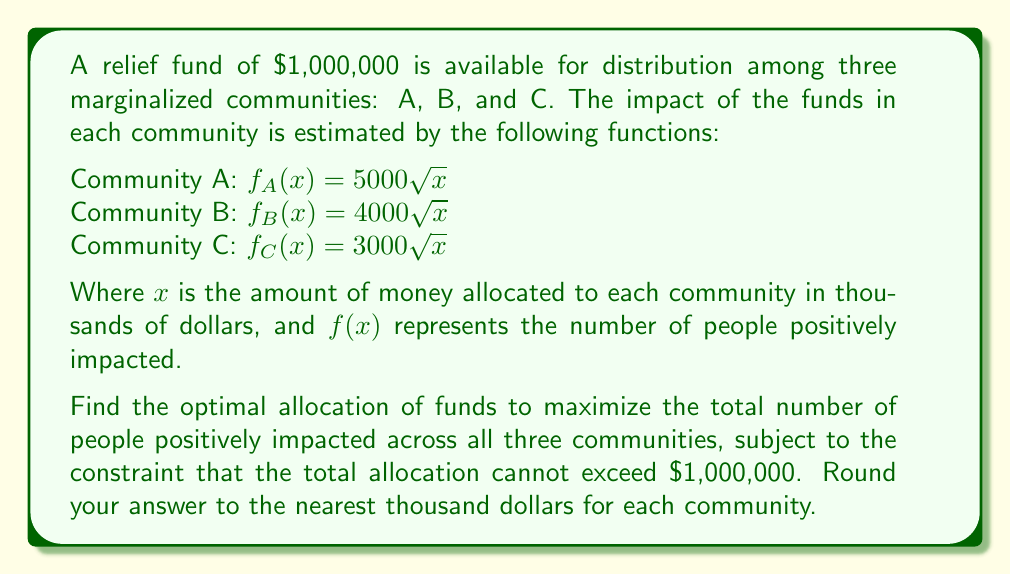Give your solution to this math problem. To solve this optimization problem, we'll use the method of Lagrange multipliers:

1) Let $x$, $y$, and $z$ represent the allocation (in thousands) to communities A, B, and C respectively.

2) Our objective function is:
   $$F(x,y,z) = 5000\sqrt{x} + 4000\sqrt{y} + 3000\sqrt{z}$$

3) The constraint is:
   $$g(x,y,z) = x + y + z - 1000 = 0$$

4) Form the Lagrangian:
   $$L(x,y,z,\lambda) = 5000\sqrt{x} + 4000\sqrt{y} + 3000\sqrt{z} - \lambda(x + y + z - 1000)$$

5) Take partial derivatives and set them equal to zero:
   $$\frac{\partial L}{\partial x} = \frac{2500}{\sqrt{x}} - \lambda = 0$$
   $$\frac{\partial L}{\partial y} = \frac{2000}{\sqrt{y}} - \lambda = 0$$
   $$\frac{\partial L}{\partial z} = \frac{1500}{\sqrt{z}} - \lambda = 0$$
   $$\frac{\partial L}{\partial \lambda} = x + y + z - 1000 = 0$$

6) From these equations, we can derive:
   $$\frac{2500}{\sqrt{x}} = \frac{2000}{\sqrt{y}} = \frac{1500}{\sqrt{z}} = \lambda$$

7) This implies:
   $$\frac{x}{(2500/\lambda)^2} = \frac{y}{(2000/\lambda)^2} = \frac{z}{(1500/\lambda)^2} = 1$$

8) Let $k = (1000/\lambda)^2$. Then:
   $$x = 25k, y = 16k, z = 9k$$

9) Substituting into the constraint equation:
   $$25k + 16k + 9k = 1000$$
   $$50k = 1000$$
   $$k = 20$$

10) Therefore:
    $$x = 25(20) = 500$$
    $$y = 16(20) = 320$$
    $$z = 9(20) = 180$$

11) Rounding to the nearest thousand:
    A: $500,000
    B: $320,000
    C: $180,000
Answer: The optimal allocation to maximize impact is:
Community A: $500,000
Community B: $320,000
Community C: $180,000 